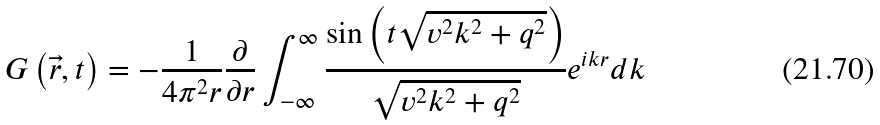Convert formula to latex. <formula><loc_0><loc_0><loc_500><loc_500>G \left ( \vec { r } , t \right ) = - \frac { 1 } { 4 \pi ^ { 2 } r } \frac { \partial } { \partial r } \int _ { - \infty } ^ { \infty } \frac { \sin \left ( t \sqrt { v ^ { 2 } k ^ { 2 } + q ^ { 2 } } \right ) } { \sqrt { v ^ { 2 } k ^ { 2 } + q ^ { 2 } } } e ^ { i k r } d k</formula> 